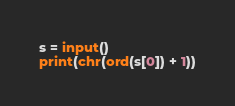<code> <loc_0><loc_0><loc_500><loc_500><_Python_>s = input()
print(chr(ord(s[0]) + 1))</code> 